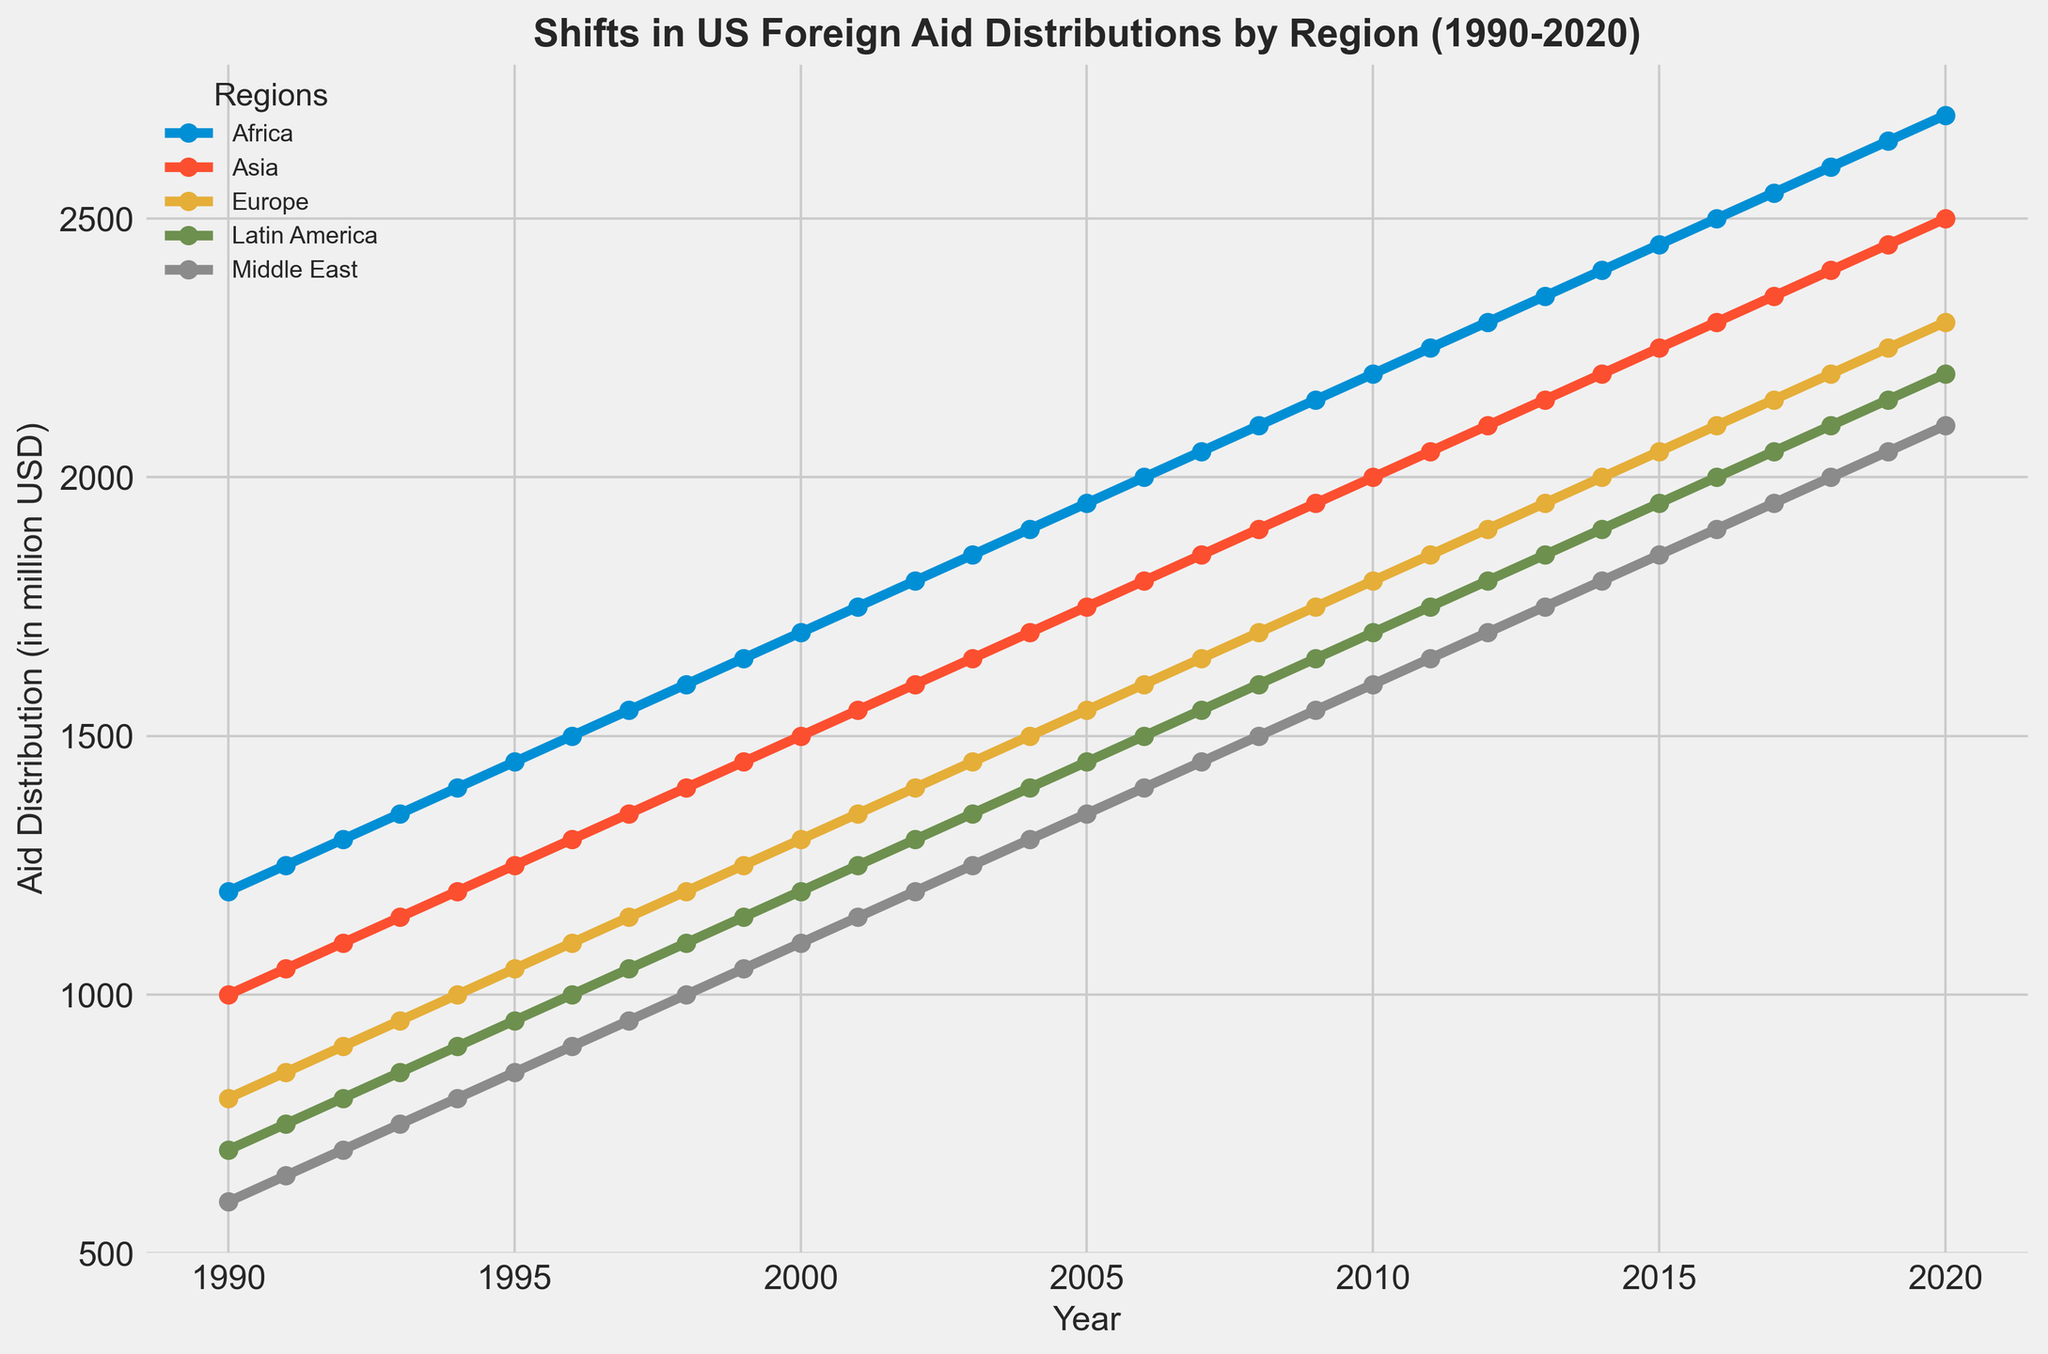What is the trend in US foreign aid to Africa from 1990 to 2020? The plot shows a consistent upward trend in aid distribution to Africa. Starting from around 1200 million USD in 1990, aid increases steadily every year, reaching approximately 2700 million USD by 2020.
Answer: Consistent upward trend Which region received the highest aid distribution in 2005? By examining the plot at the year 2005, Africa has the highest marker at approximately 1950 million USD. The other regions have lower aid distributions: Asia around 1750 million USD, Europe around 1550 million USD, Latin America around 1450 million USD, and Middle East around 1350 million USD.
Answer: Africa In which year did the Middle East's foreign aid double its 1990 value? The aid to the Middle East in 1990 is around 600 million USD. By tracing this value on the plot, it approximately doubles in the year 2020, reaching around 1200 million USD.
Answer: 2020 Compare the aid distribution to Asia and Europe in 2010. Which received more? Looking at the year 2010 on the plot, Asia's aid is around 2000 million USD, while Europe's aid is at 1800 million USD. Therefore, Asia received more aid than Europe in 2010.
Answer: Asia What is the difference in the aid distribution to Latin America between the years 2000 and 2020? In 2000, Latin America received around 1200 million USD. In 2020, this increases to approximately 2200 million USD. The difference is calculated by subtracting 1200 from 2200, resulting in 1000 million USD.
Answer: 1000 million USD Which region shows the least growth in aid distribution from 1990 to 2020? By comparing the slopes of the lines from 1990 to 2020, the Middle East shows the least steep increase, indicating the smallest growth in aid over the period. Its aid increased from 600 million USD in 1990 to 1200 million USD in 2020, a total growth of 600 million USD. Other regions have larger growth.
Answer: Middle East What is the average annual foreign aid distribution to Europe over the entire period? To calculate the average, sum all the annual aid distributions to Europe from 1990 to 2020 and divide by the number of years (31). The total sum is (800 + 850 + 900 + ... + 2300), which adds up to 77500 million USD. Dividing by 31 gives approximately 2500 million USD as the average.
Answer: 1500 million USD Which region had the most aid distribution in 2010 and by how much did it exceed the next highest region? In 2010, Africa received the most aid with about 2200 million USD. The next highest region is Asia with 2000 million USD. The excess is calculated as 2200 - 2000 = 200 million USD.
Answer: Africa, 200 million USD 